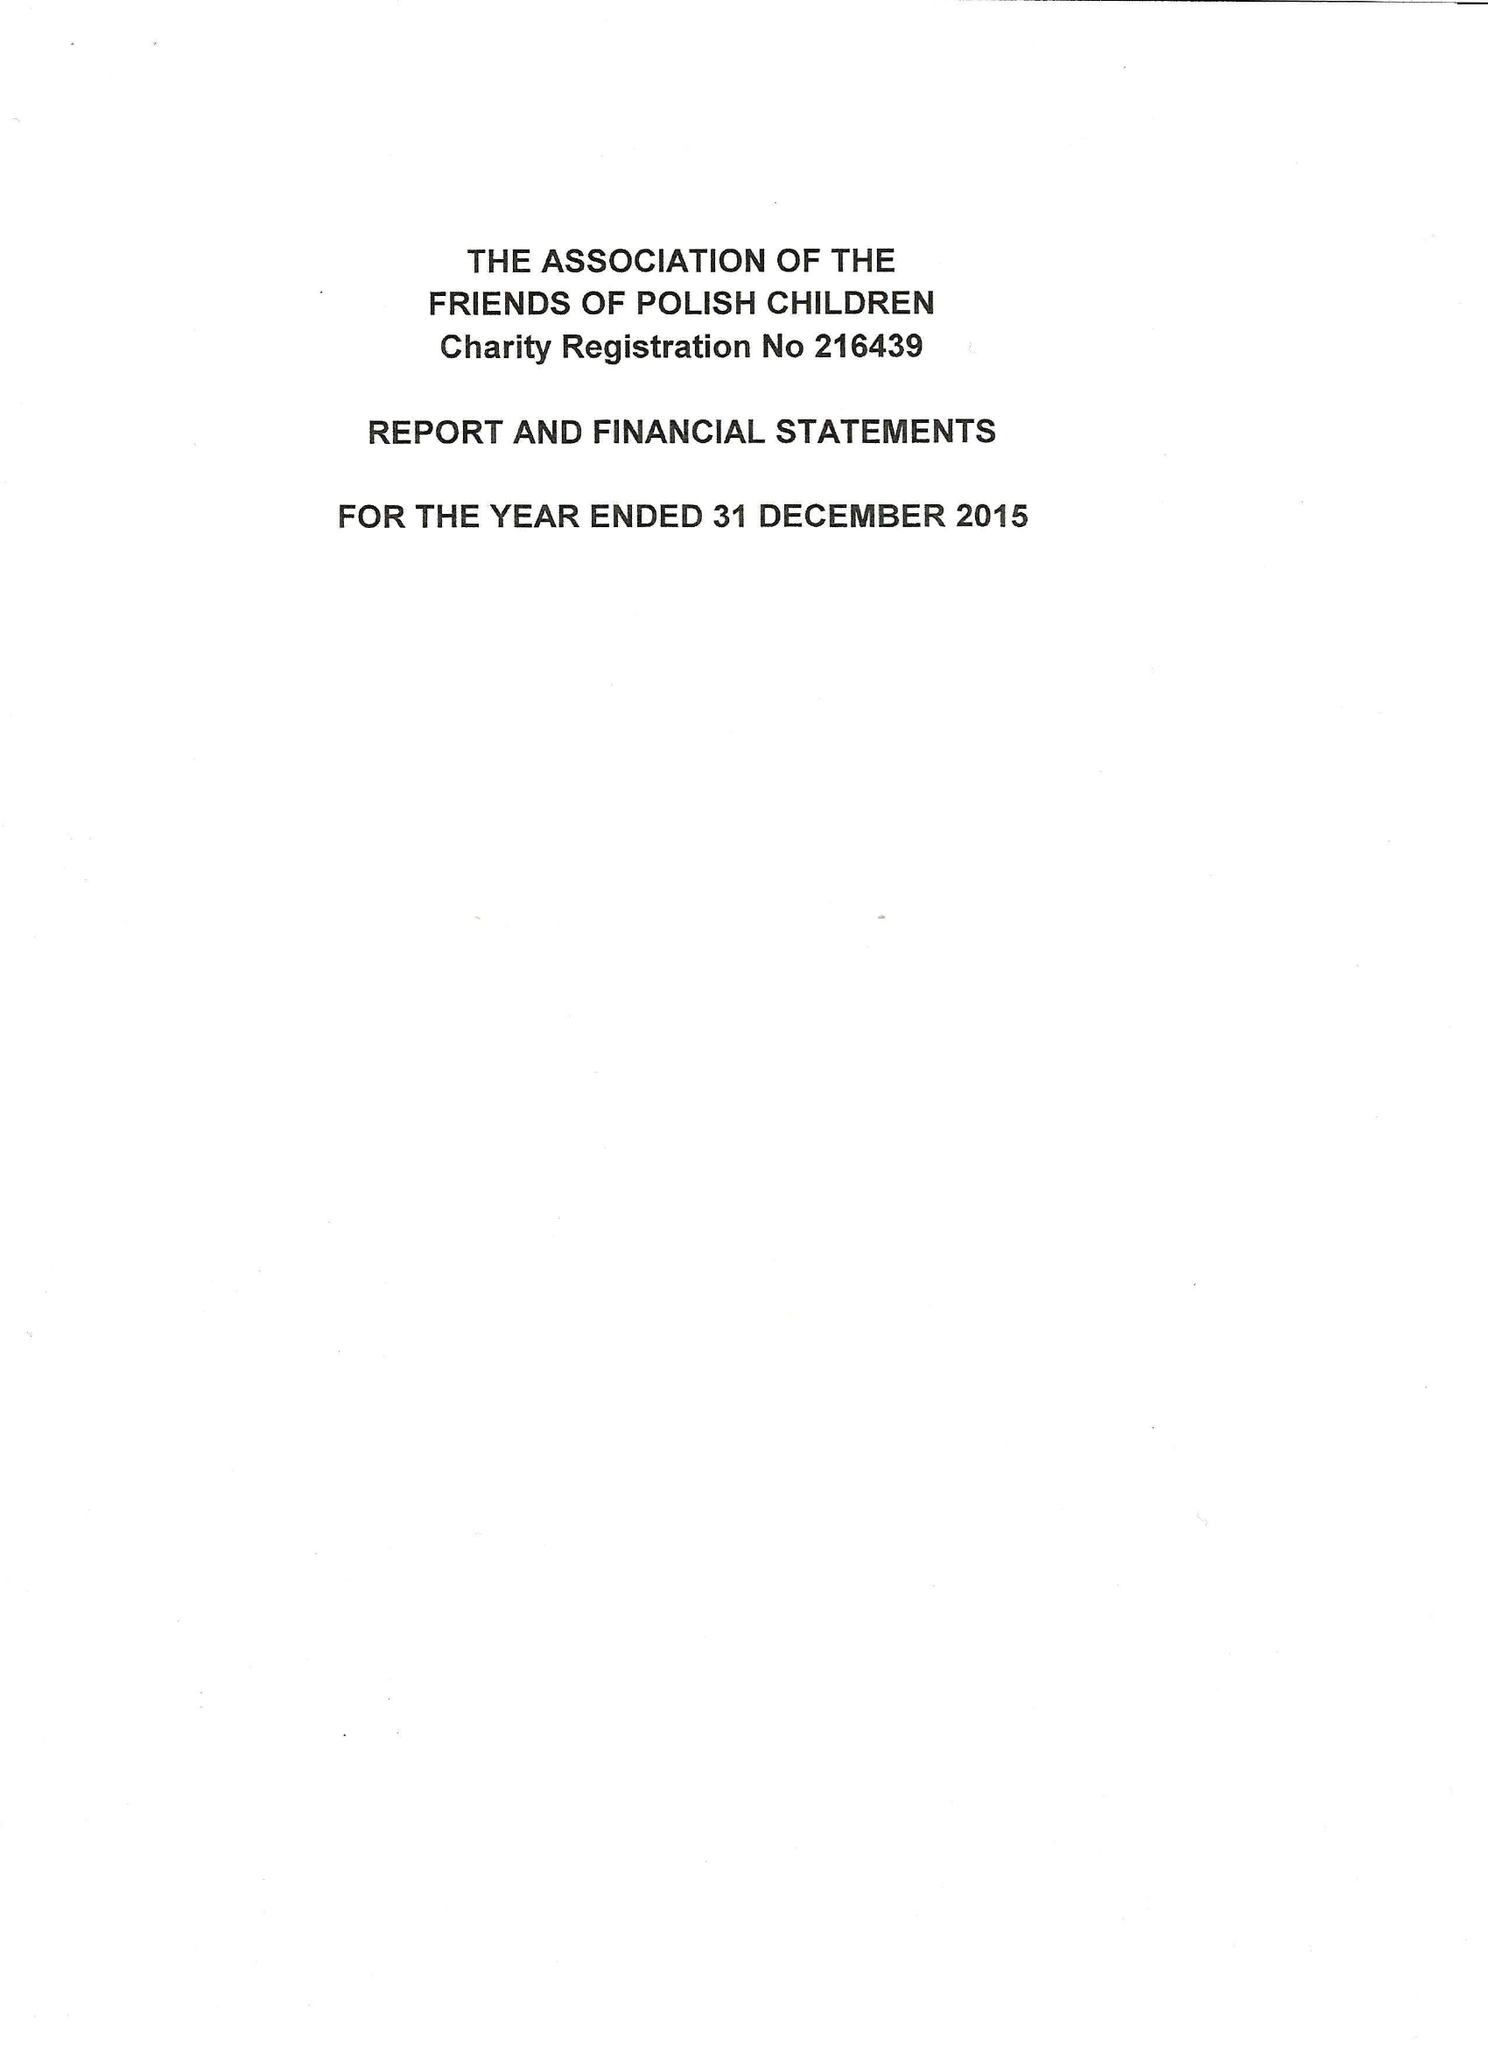What is the value for the address__street_line?
Answer the question using a single word or phrase. 2D FONTENOY ROAD 